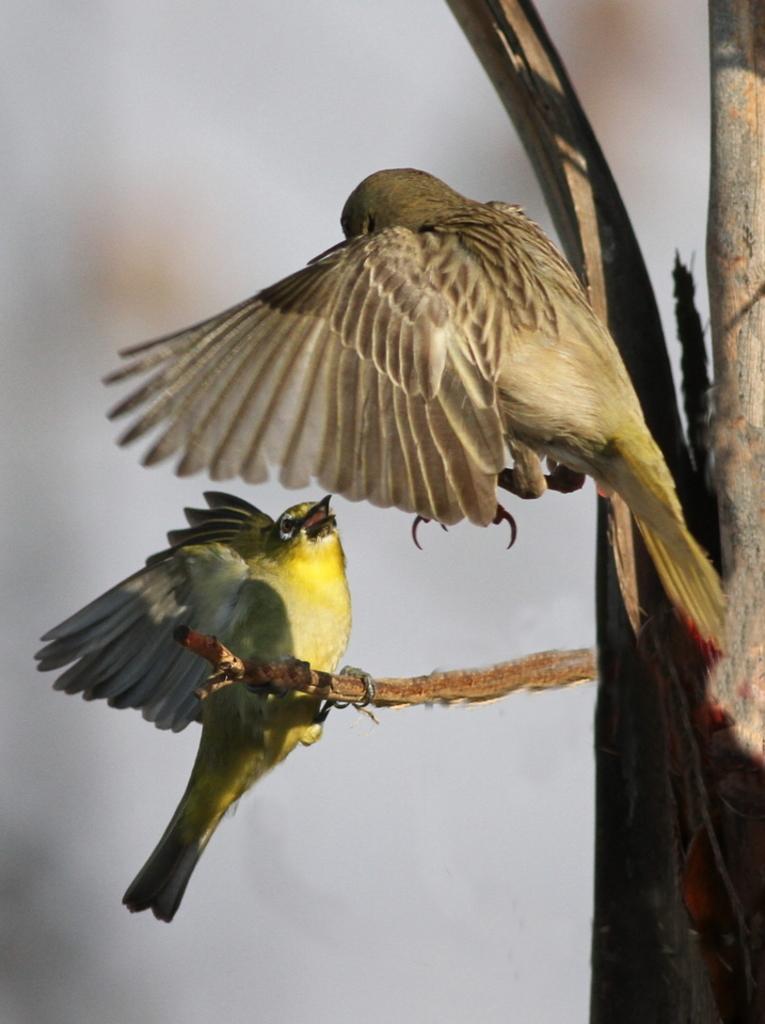Please provide a concise description of this image. In this picture there are two birds in the center of the image. 